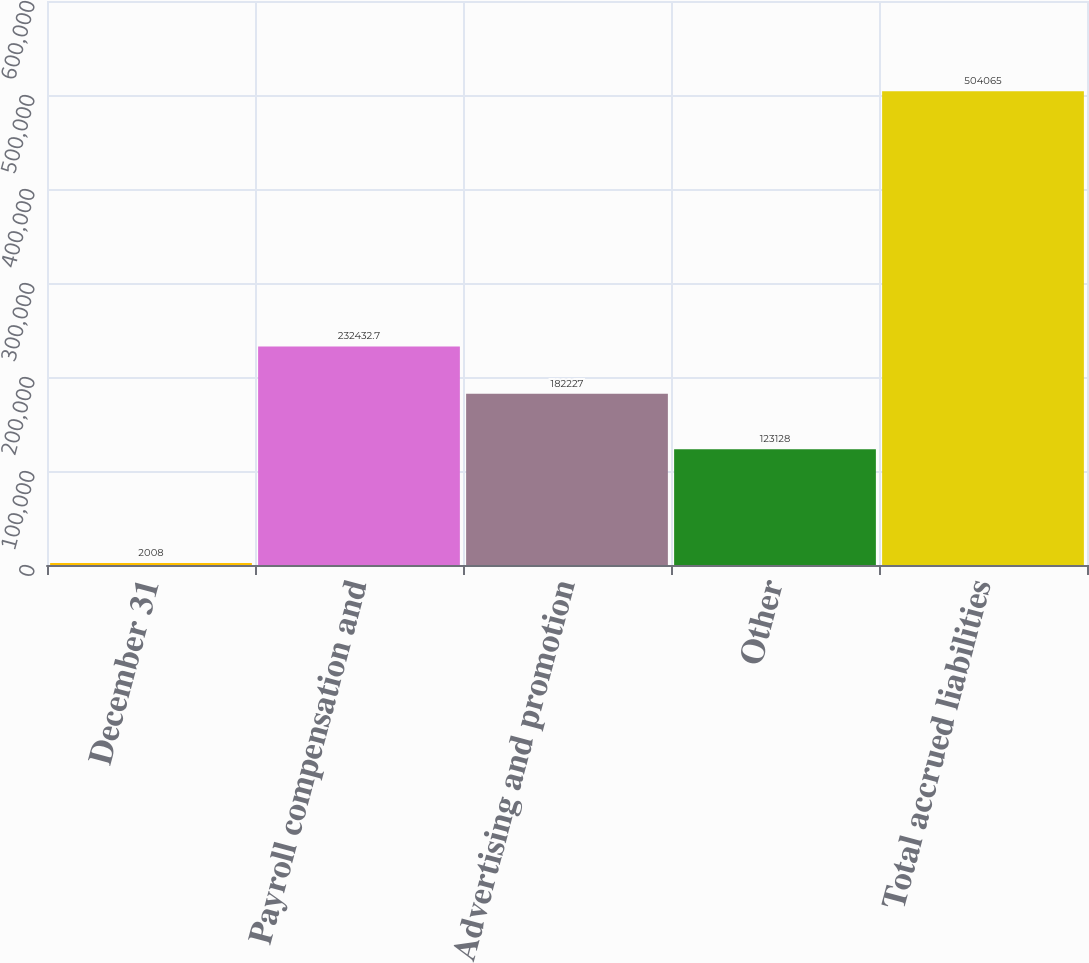Convert chart. <chart><loc_0><loc_0><loc_500><loc_500><bar_chart><fcel>December 31<fcel>Payroll compensation and<fcel>Advertising and promotion<fcel>Other<fcel>Total accrued liabilities<nl><fcel>2008<fcel>232433<fcel>182227<fcel>123128<fcel>504065<nl></chart> 